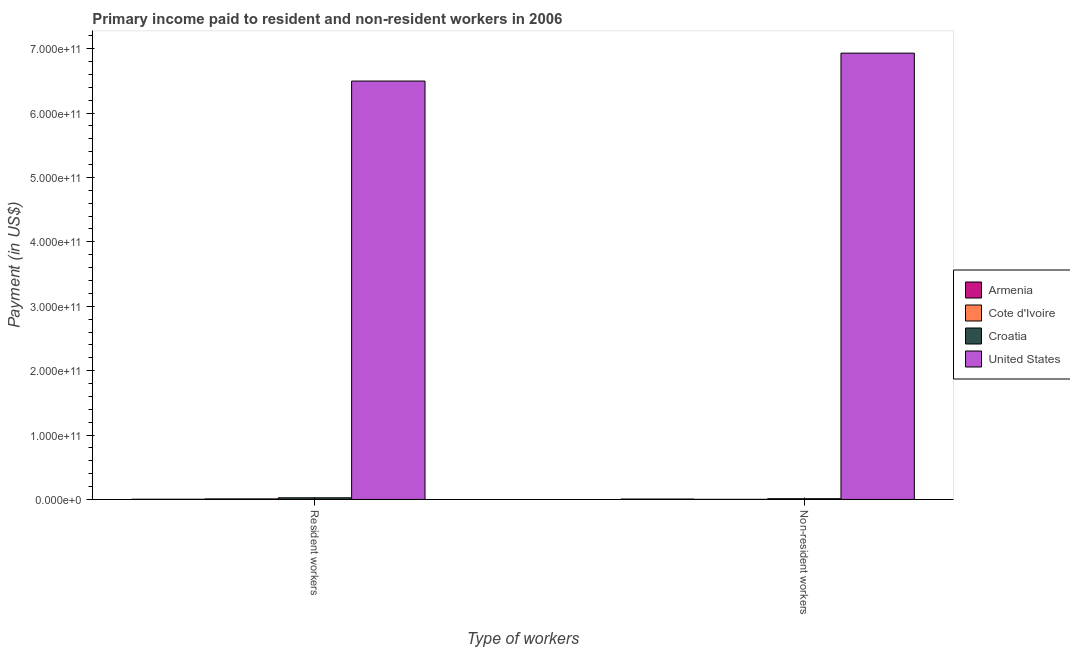How many groups of bars are there?
Make the answer very short. 2. How many bars are there on the 1st tick from the right?
Your answer should be very brief. 4. What is the label of the 2nd group of bars from the left?
Keep it short and to the point. Non-resident workers. What is the payment made to resident workers in Croatia?
Give a very brief answer. 2.59e+09. Across all countries, what is the maximum payment made to non-resident workers?
Offer a terse response. 6.93e+11. Across all countries, what is the minimum payment made to resident workers?
Your answer should be very brief. 3.54e+08. In which country was the payment made to non-resident workers minimum?
Provide a succinct answer. Cote d'Ivoire. What is the total payment made to resident workers in the graph?
Your response must be concise. 6.54e+11. What is the difference between the payment made to resident workers in Armenia and that in United States?
Offer a very short reply. -6.49e+11. What is the difference between the payment made to resident workers in United States and the payment made to non-resident workers in Armenia?
Your answer should be compact. 6.49e+11. What is the average payment made to non-resident workers per country?
Your response must be concise. 1.74e+11. What is the difference between the payment made to resident workers and payment made to non-resident workers in Cote d'Ivoire?
Offer a terse response. 7.10e+08. In how many countries, is the payment made to non-resident workers greater than 140000000000 US$?
Your answer should be very brief. 1. What is the ratio of the payment made to resident workers in Croatia to that in Cote d'Ivoire?
Ensure brevity in your answer.  2.86. Is the payment made to non-resident workers in Cote d'Ivoire less than that in United States?
Make the answer very short. Yes. What does the 3rd bar from the left in Resident workers represents?
Your response must be concise. Croatia. How many bars are there?
Your answer should be very brief. 8. Are all the bars in the graph horizontal?
Your response must be concise. No. What is the difference between two consecutive major ticks on the Y-axis?
Provide a succinct answer. 1.00e+11. Does the graph contain any zero values?
Your response must be concise. No. Does the graph contain grids?
Your answer should be very brief. No. Where does the legend appear in the graph?
Your response must be concise. Center right. How many legend labels are there?
Your response must be concise. 4. How are the legend labels stacked?
Your response must be concise. Vertical. What is the title of the graph?
Give a very brief answer. Primary income paid to resident and non-resident workers in 2006. What is the label or title of the X-axis?
Provide a short and direct response. Type of workers. What is the label or title of the Y-axis?
Offer a terse response. Payment (in US$). What is the Payment (in US$) in Armenia in Resident workers?
Ensure brevity in your answer.  3.54e+08. What is the Payment (in US$) in Cote d'Ivoire in Resident workers?
Your answer should be compact. 9.06e+08. What is the Payment (in US$) of Croatia in Resident workers?
Provide a short and direct response. 2.59e+09. What is the Payment (in US$) in United States in Resident workers?
Your answer should be very brief. 6.50e+11. What is the Payment (in US$) of Armenia in Non-resident workers?
Provide a succinct answer. 6.56e+08. What is the Payment (in US$) of Cote d'Ivoire in Non-resident workers?
Your response must be concise. 1.96e+08. What is the Payment (in US$) of Croatia in Non-resident workers?
Your answer should be very brief. 1.17e+09. What is the Payment (in US$) in United States in Non-resident workers?
Your answer should be very brief. 6.93e+11. Across all Type of workers, what is the maximum Payment (in US$) of Armenia?
Provide a short and direct response. 6.56e+08. Across all Type of workers, what is the maximum Payment (in US$) in Cote d'Ivoire?
Make the answer very short. 9.06e+08. Across all Type of workers, what is the maximum Payment (in US$) in Croatia?
Give a very brief answer. 2.59e+09. Across all Type of workers, what is the maximum Payment (in US$) of United States?
Your answer should be very brief. 6.93e+11. Across all Type of workers, what is the minimum Payment (in US$) in Armenia?
Make the answer very short. 3.54e+08. Across all Type of workers, what is the minimum Payment (in US$) in Cote d'Ivoire?
Offer a very short reply. 1.96e+08. Across all Type of workers, what is the minimum Payment (in US$) in Croatia?
Make the answer very short. 1.17e+09. Across all Type of workers, what is the minimum Payment (in US$) in United States?
Your answer should be compact. 6.50e+11. What is the total Payment (in US$) in Armenia in the graph?
Offer a very short reply. 1.01e+09. What is the total Payment (in US$) in Cote d'Ivoire in the graph?
Keep it short and to the point. 1.10e+09. What is the total Payment (in US$) of Croatia in the graph?
Provide a short and direct response. 3.76e+09. What is the total Payment (in US$) of United States in the graph?
Provide a short and direct response. 1.34e+12. What is the difference between the Payment (in US$) of Armenia in Resident workers and that in Non-resident workers?
Ensure brevity in your answer.  -3.02e+08. What is the difference between the Payment (in US$) in Cote d'Ivoire in Resident workers and that in Non-resident workers?
Your response must be concise. 7.10e+08. What is the difference between the Payment (in US$) in Croatia in Resident workers and that in Non-resident workers?
Offer a terse response. 1.42e+09. What is the difference between the Payment (in US$) in United States in Resident workers and that in Non-resident workers?
Your response must be concise. -4.33e+1. What is the difference between the Payment (in US$) in Armenia in Resident workers and the Payment (in US$) in Cote d'Ivoire in Non-resident workers?
Give a very brief answer. 1.58e+08. What is the difference between the Payment (in US$) of Armenia in Resident workers and the Payment (in US$) of Croatia in Non-resident workers?
Offer a terse response. -8.14e+08. What is the difference between the Payment (in US$) of Armenia in Resident workers and the Payment (in US$) of United States in Non-resident workers?
Your response must be concise. -6.93e+11. What is the difference between the Payment (in US$) in Cote d'Ivoire in Resident workers and the Payment (in US$) in Croatia in Non-resident workers?
Provide a short and direct response. -2.62e+08. What is the difference between the Payment (in US$) of Cote d'Ivoire in Resident workers and the Payment (in US$) of United States in Non-resident workers?
Provide a succinct answer. -6.92e+11. What is the difference between the Payment (in US$) of Croatia in Resident workers and the Payment (in US$) of United States in Non-resident workers?
Provide a succinct answer. -6.90e+11. What is the average Payment (in US$) of Armenia per Type of workers?
Provide a short and direct response. 5.05e+08. What is the average Payment (in US$) of Cote d'Ivoire per Type of workers?
Make the answer very short. 5.51e+08. What is the average Payment (in US$) in Croatia per Type of workers?
Make the answer very short. 1.88e+09. What is the average Payment (in US$) of United States per Type of workers?
Offer a very short reply. 6.71e+11. What is the difference between the Payment (in US$) of Armenia and Payment (in US$) of Cote d'Ivoire in Resident workers?
Your answer should be very brief. -5.53e+08. What is the difference between the Payment (in US$) of Armenia and Payment (in US$) of Croatia in Resident workers?
Ensure brevity in your answer.  -2.24e+09. What is the difference between the Payment (in US$) in Armenia and Payment (in US$) in United States in Resident workers?
Keep it short and to the point. -6.49e+11. What is the difference between the Payment (in US$) of Cote d'Ivoire and Payment (in US$) of Croatia in Resident workers?
Your response must be concise. -1.68e+09. What is the difference between the Payment (in US$) in Cote d'Ivoire and Payment (in US$) in United States in Resident workers?
Provide a short and direct response. -6.49e+11. What is the difference between the Payment (in US$) of Croatia and Payment (in US$) of United States in Resident workers?
Provide a short and direct response. -6.47e+11. What is the difference between the Payment (in US$) in Armenia and Payment (in US$) in Cote d'Ivoire in Non-resident workers?
Offer a very short reply. 4.60e+08. What is the difference between the Payment (in US$) of Armenia and Payment (in US$) of Croatia in Non-resident workers?
Your response must be concise. -5.12e+08. What is the difference between the Payment (in US$) of Armenia and Payment (in US$) of United States in Non-resident workers?
Give a very brief answer. -6.92e+11. What is the difference between the Payment (in US$) of Cote d'Ivoire and Payment (in US$) of Croatia in Non-resident workers?
Offer a terse response. -9.72e+08. What is the difference between the Payment (in US$) in Cote d'Ivoire and Payment (in US$) in United States in Non-resident workers?
Ensure brevity in your answer.  -6.93e+11. What is the difference between the Payment (in US$) of Croatia and Payment (in US$) of United States in Non-resident workers?
Your answer should be compact. -6.92e+11. What is the ratio of the Payment (in US$) of Armenia in Resident workers to that in Non-resident workers?
Your response must be concise. 0.54. What is the ratio of the Payment (in US$) of Cote d'Ivoire in Resident workers to that in Non-resident workers?
Your answer should be very brief. 4.62. What is the ratio of the Payment (in US$) of Croatia in Resident workers to that in Non-resident workers?
Your answer should be very brief. 2.22. What is the difference between the highest and the second highest Payment (in US$) of Armenia?
Ensure brevity in your answer.  3.02e+08. What is the difference between the highest and the second highest Payment (in US$) in Cote d'Ivoire?
Provide a succinct answer. 7.10e+08. What is the difference between the highest and the second highest Payment (in US$) in Croatia?
Make the answer very short. 1.42e+09. What is the difference between the highest and the second highest Payment (in US$) in United States?
Provide a succinct answer. 4.33e+1. What is the difference between the highest and the lowest Payment (in US$) of Armenia?
Your answer should be very brief. 3.02e+08. What is the difference between the highest and the lowest Payment (in US$) in Cote d'Ivoire?
Keep it short and to the point. 7.10e+08. What is the difference between the highest and the lowest Payment (in US$) of Croatia?
Your answer should be very brief. 1.42e+09. What is the difference between the highest and the lowest Payment (in US$) of United States?
Offer a very short reply. 4.33e+1. 